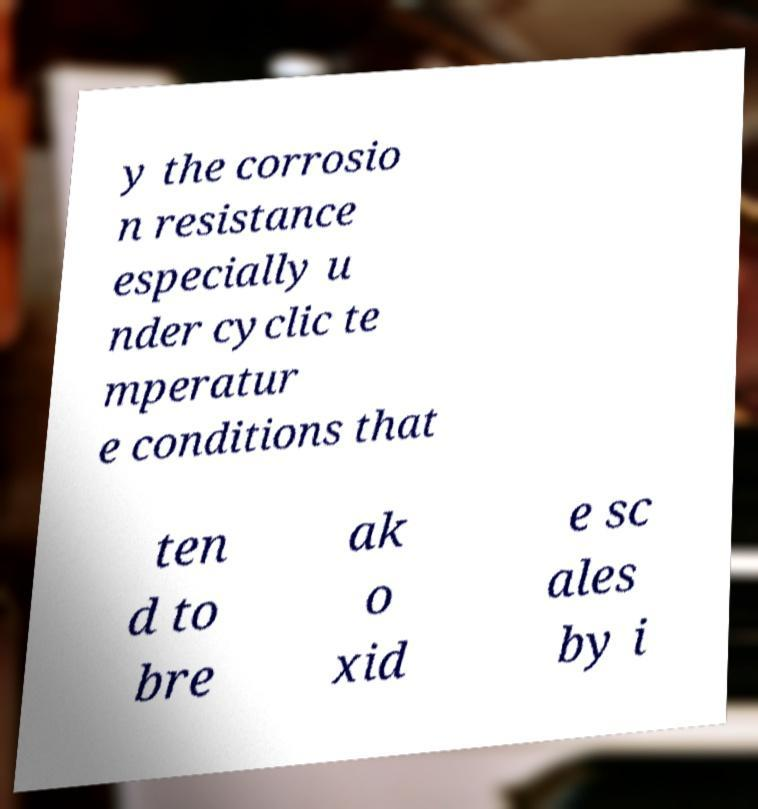For documentation purposes, I need the text within this image transcribed. Could you provide that? y the corrosio n resistance especially u nder cyclic te mperatur e conditions that ten d to bre ak o xid e sc ales by i 